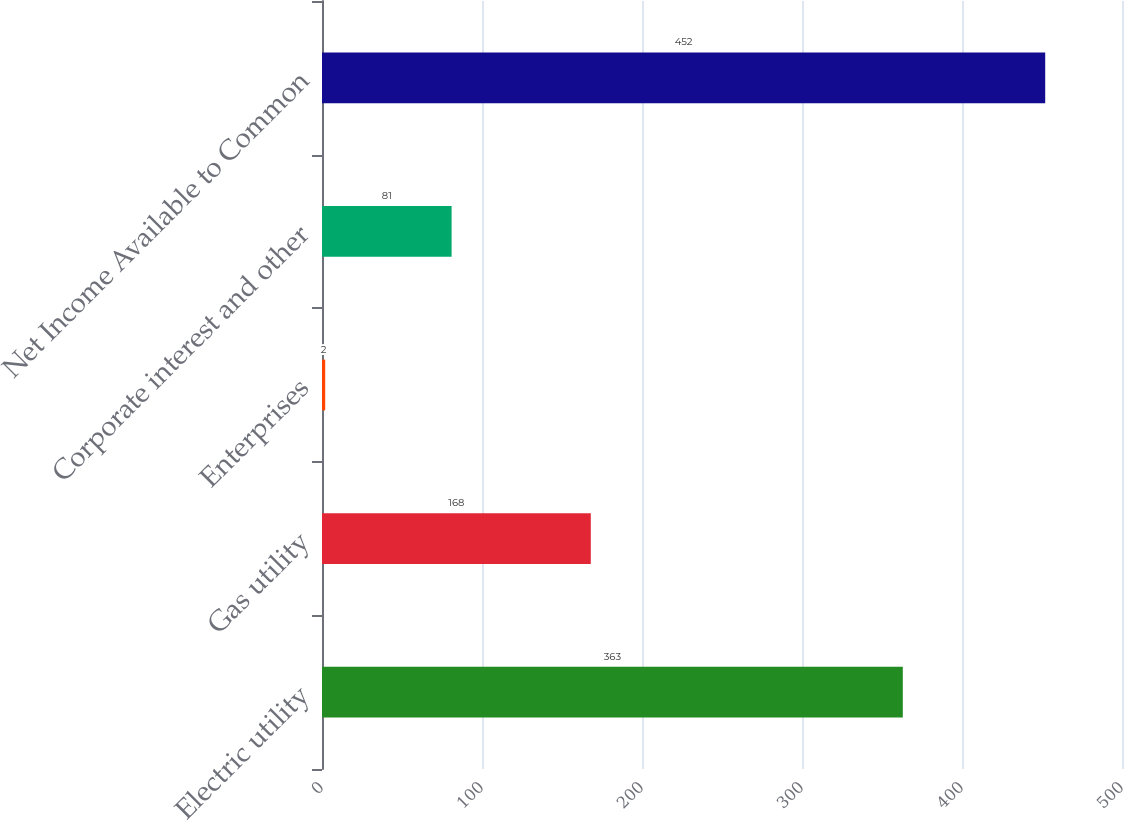<chart> <loc_0><loc_0><loc_500><loc_500><bar_chart><fcel>Electric utility<fcel>Gas utility<fcel>Enterprises<fcel>Corporate interest and other<fcel>Net Income Available to Common<nl><fcel>363<fcel>168<fcel>2<fcel>81<fcel>452<nl></chart> 